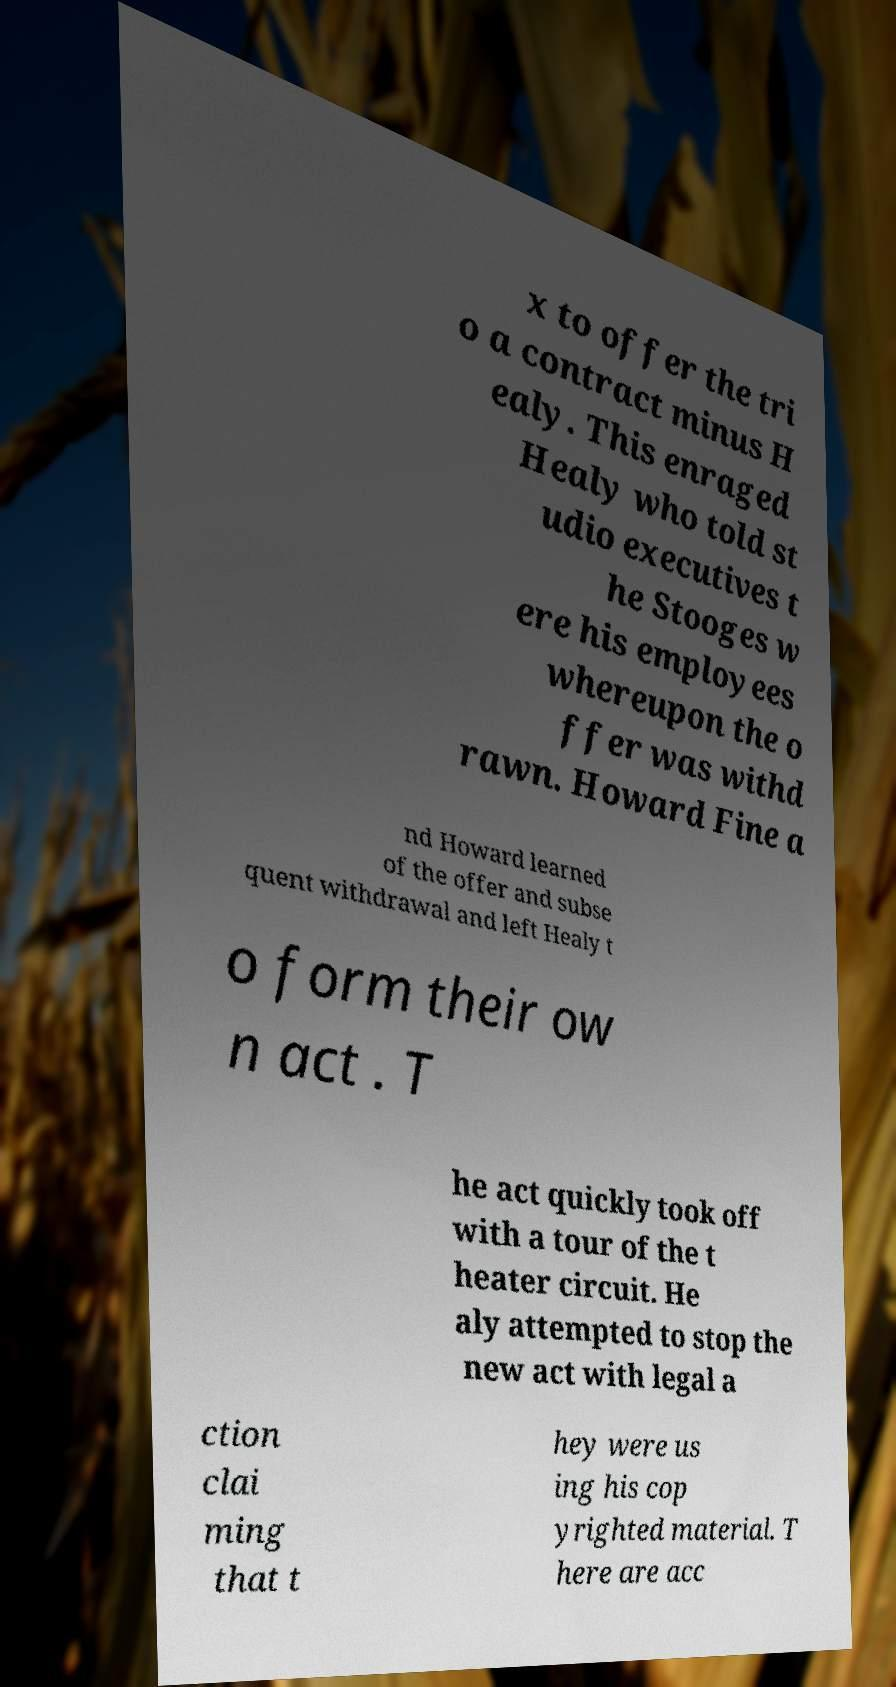Please identify and transcribe the text found in this image. x to offer the tri o a contract minus H ealy. This enraged Healy who told st udio executives t he Stooges w ere his employees whereupon the o ffer was withd rawn. Howard Fine a nd Howard learned of the offer and subse quent withdrawal and left Healy t o form their ow n act . T he act quickly took off with a tour of the t heater circuit. He aly attempted to stop the new act with legal a ction clai ming that t hey were us ing his cop yrighted material. T here are acc 